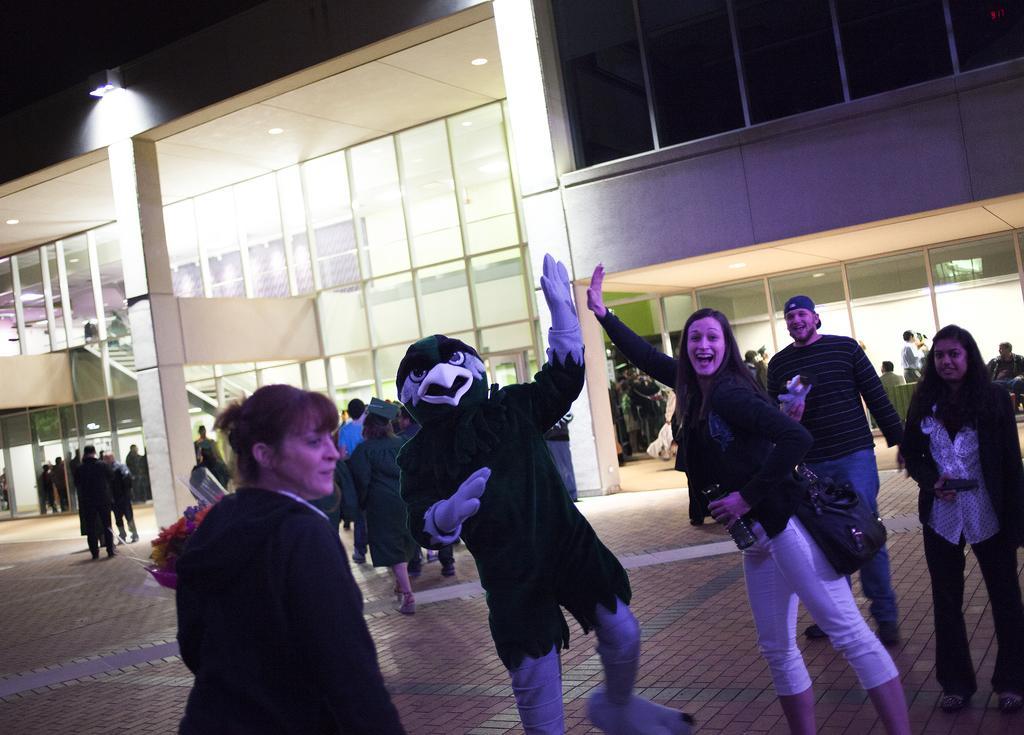Please provide a concise description of this image. In this image I can see a man wearing a animal dress and beside him I can see a woman she is smiling and I can see two persons visible on the right side and I can see a woman at the bottom and in the middle I can see a building , in front of the building I can see a person standing and walking on the floor. 